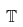Convert formula to latex. <formula><loc_0><loc_0><loc_500><loc_500>\mathbb { T }</formula> 